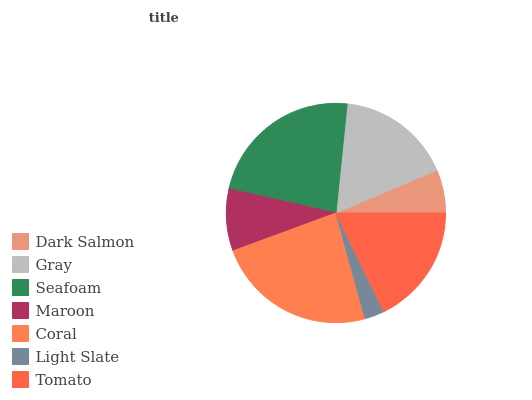Is Light Slate the minimum?
Answer yes or no. Yes. Is Coral the maximum?
Answer yes or no. Yes. Is Gray the minimum?
Answer yes or no. No. Is Gray the maximum?
Answer yes or no. No. Is Gray greater than Dark Salmon?
Answer yes or no. Yes. Is Dark Salmon less than Gray?
Answer yes or no. Yes. Is Dark Salmon greater than Gray?
Answer yes or no. No. Is Gray less than Dark Salmon?
Answer yes or no. No. Is Gray the high median?
Answer yes or no. Yes. Is Gray the low median?
Answer yes or no. Yes. Is Dark Salmon the high median?
Answer yes or no. No. Is Dark Salmon the low median?
Answer yes or no. No. 